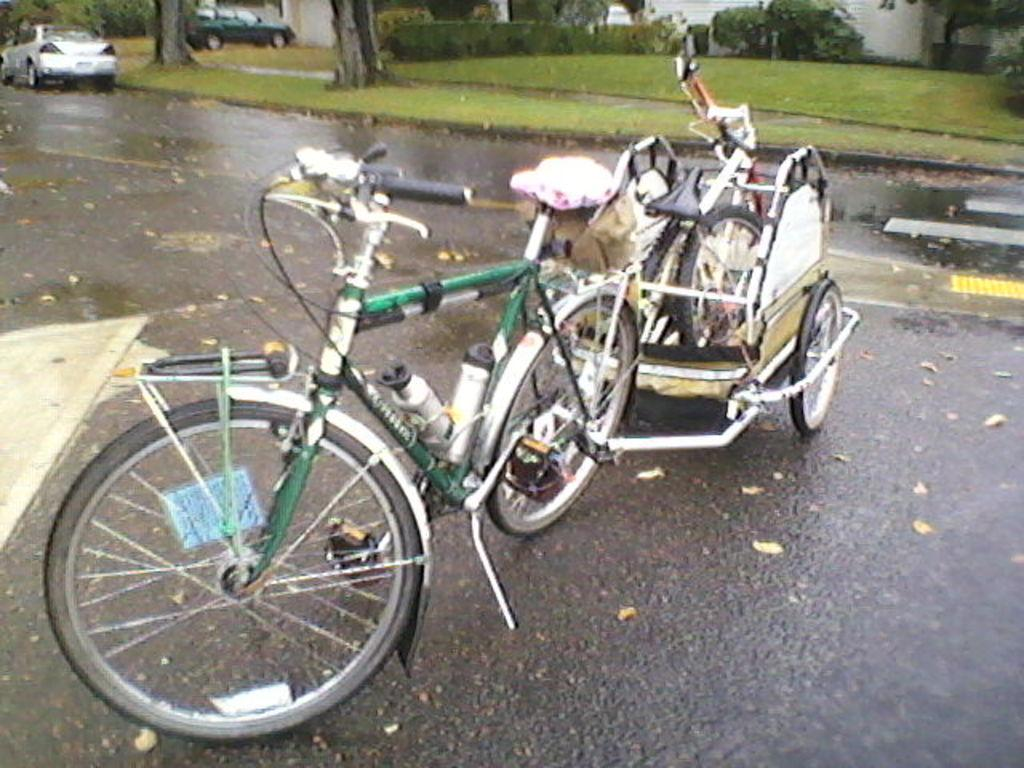What is the main subject in the center of the image? There is a bicycle with a cart attached to it in the center of the image. What is located at the bottom of the image? There is a road at the bottom of the image. What can be seen in the background of the image? There are cars, trees, and grass in the background of the image. Where is the farm and grain located in the image? There is no farm or grain present in the image. The image features a bicycle with a cart, a road, and a background with cars, trees, and grass. 